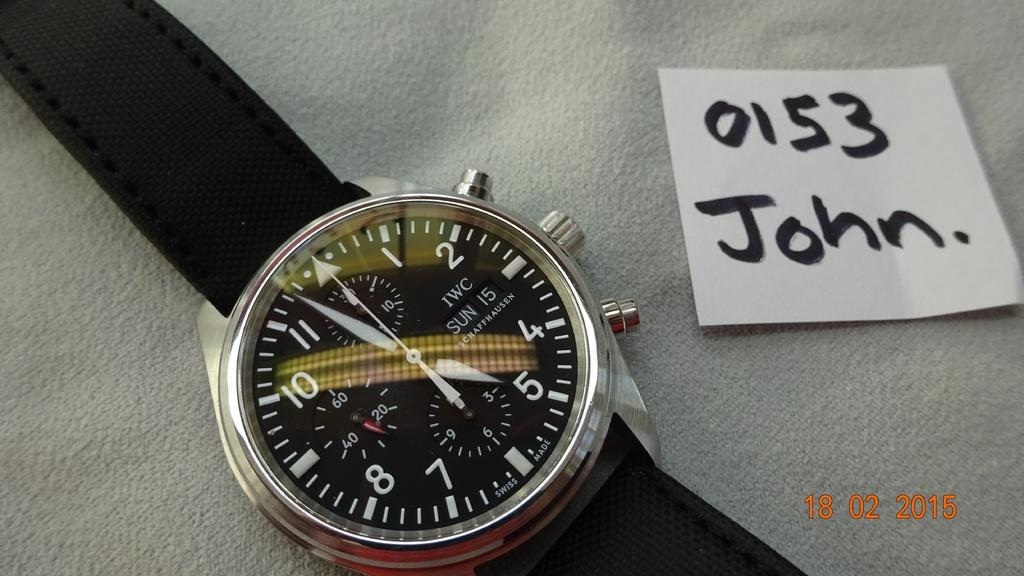Provide a one-sentence caption for the provided image. A watch is sitting next to a note that says 0153 John. 